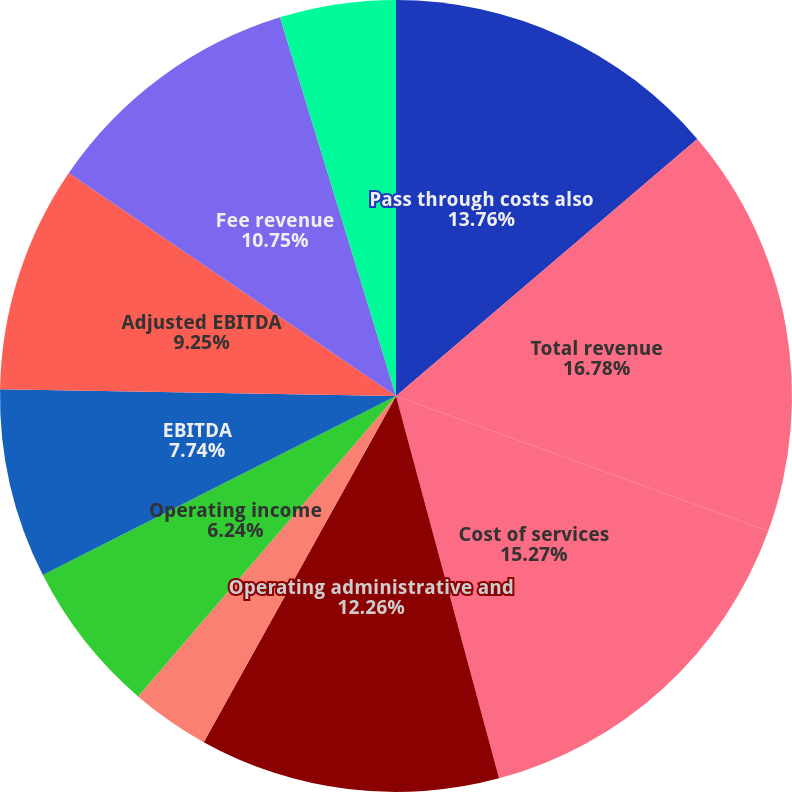Convert chart to OTSL. <chart><loc_0><loc_0><loc_500><loc_500><pie_chart><fcel>Pass through costs also<fcel>Total revenue<fcel>Cost of services<fcel>Operating administrative and<fcel>Depreciation and amortization<fcel>Operating income<fcel>EBITDA<fcel>Adjusted EBITDA<fcel>Fee revenue<fcel>Revenue<nl><fcel>13.76%<fcel>16.78%<fcel>15.27%<fcel>12.26%<fcel>3.22%<fcel>6.24%<fcel>7.74%<fcel>9.25%<fcel>10.75%<fcel>4.73%<nl></chart> 